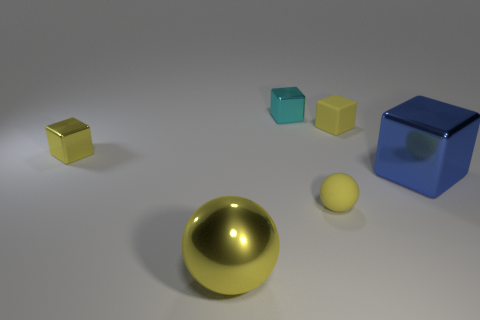Subtract 2 cubes. How many cubes are left? 2 Add 1 yellow shiny objects. How many objects exist? 7 Subtract all purple blocks. Subtract all gray cylinders. How many blocks are left? 4 Subtract all blocks. How many objects are left? 2 Add 6 yellow rubber things. How many yellow rubber things are left? 8 Add 2 tiny yellow shiny cubes. How many tiny yellow shiny cubes exist? 3 Subtract 1 blue cubes. How many objects are left? 5 Subtract all tiny cyan shiny cubes. Subtract all small matte cubes. How many objects are left? 4 